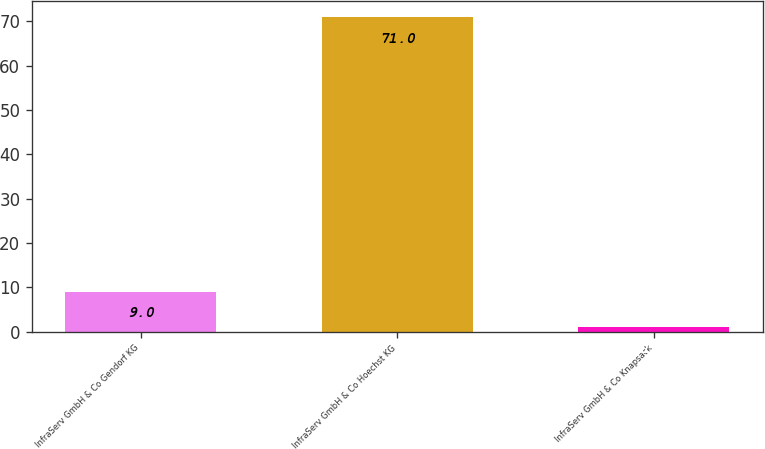Convert chart. <chart><loc_0><loc_0><loc_500><loc_500><bar_chart><fcel>InfraServ GmbH & Co Gendorf KG<fcel>InfraServ GmbH & Co Hoechst KG<fcel>InfraServ GmbH & Co Knapsack<nl><fcel>9<fcel>71<fcel>1<nl></chart> 